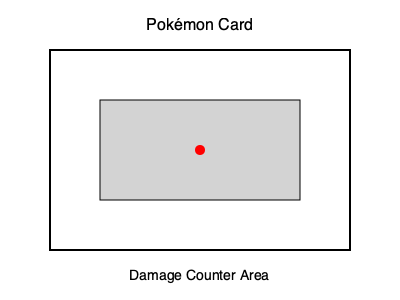In a standard Pokémon TCG match, you need to cover a rectangular area on your opponent's Active Pokémon card with damage counters. The area to be covered is 200 units wide and 100 units tall. If each damage counter is a circular token with a diameter of 20 units, approximately how many damage counters would you need to completely cover this area? To solve this problem, we'll follow these steps:

1. Calculate the area to be covered:
   Area = width × height
   Area = 200 units × 100 units = 20,000 square units

2. Calculate the area of one damage counter:
   Area of a circle = $\pi r^2$
   Diameter = 20 units, so radius = 10 units
   Area of one counter = $\pi (10)^2 = 100\pi$ square units

3. Estimate the number of counters needed:
   Number of counters = Area to be covered ÷ Area of one counter
   Number of counters = 20,000 ÷ $(100\pi)$
   Number of counters ≈ 63.66

4. Round up to the nearest whole number:
   We need 64 damage counters to completely cover the area.

5. Consider packing efficiency:
   In reality, circular tokens don't pack perfectly, so we might need slightly more. A common packing efficiency for circles is around 90%.

   Adjusted number of counters = 64 ÷ 0.90 ≈ 71.11

6. Round up to the nearest whole number:
   We need 72 damage counters to ensure complete coverage.
Answer: 72 damage counters 